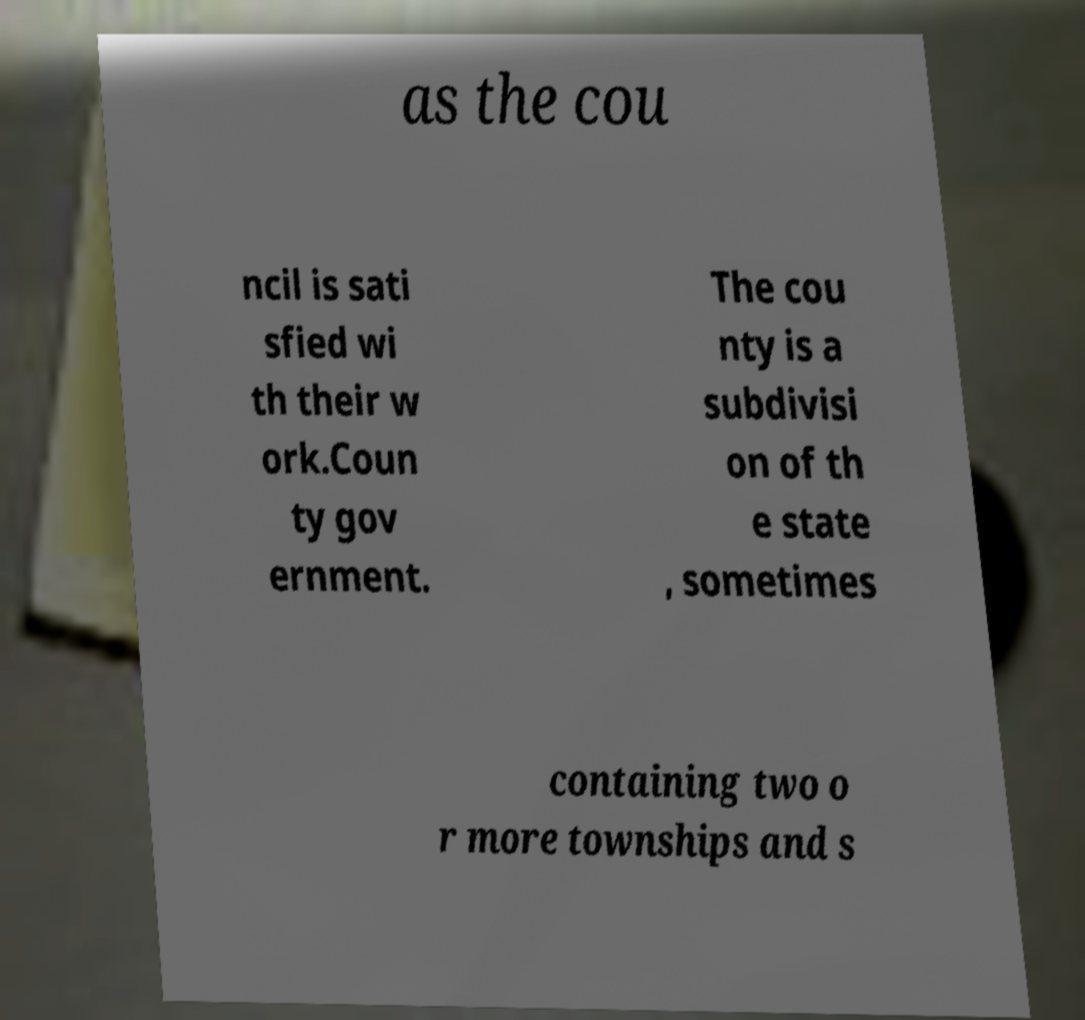For documentation purposes, I need the text within this image transcribed. Could you provide that? as the cou ncil is sati sfied wi th their w ork.Coun ty gov ernment. The cou nty is a subdivisi on of th e state , sometimes containing two o r more townships and s 